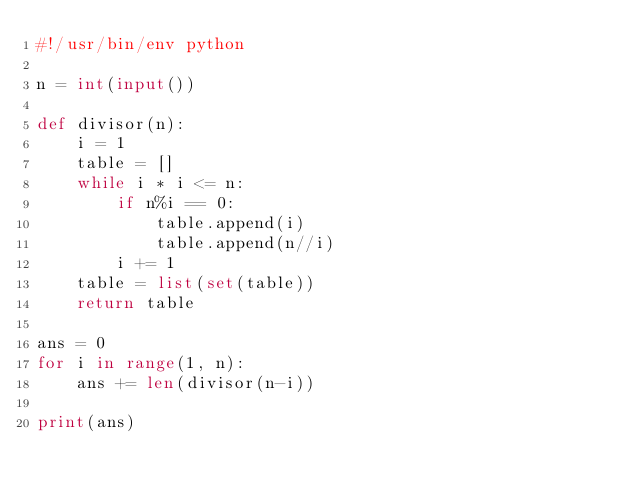<code> <loc_0><loc_0><loc_500><loc_500><_Python_>#!/usr/bin/env python

n = int(input())

def divisor(n):
    i = 1 
    table = []
    while i * i <= n:
        if n%i == 0:
            table.append(i)
            table.append(n//i)
        i += 1
    table = list(set(table))
    return table

ans = 0 
for i in range(1, n): 
    ans += len(divisor(n-i))

print(ans)
</code> 